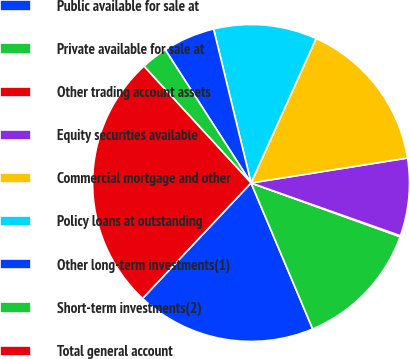Convert chart. <chart><loc_0><loc_0><loc_500><loc_500><pie_chart><fcel>Public available for sale at<fcel>Private available for sale at<fcel>Other trading account assets<fcel>Equity securities available<fcel>Commercial mortgage and other<fcel>Policy loans at outstanding<fcel>Other long-term investments(1)<fcel>Short-term investments(2)<fcel>Total general account<nl><fcel>18.36%<fcel>13.14%<fcel>0.1%<fcel>7.92%<fcel>15.75%<fcel>10.53%<fcel>5.31%<fcel>2.71%<fcel>26.18%<nl></chart> 